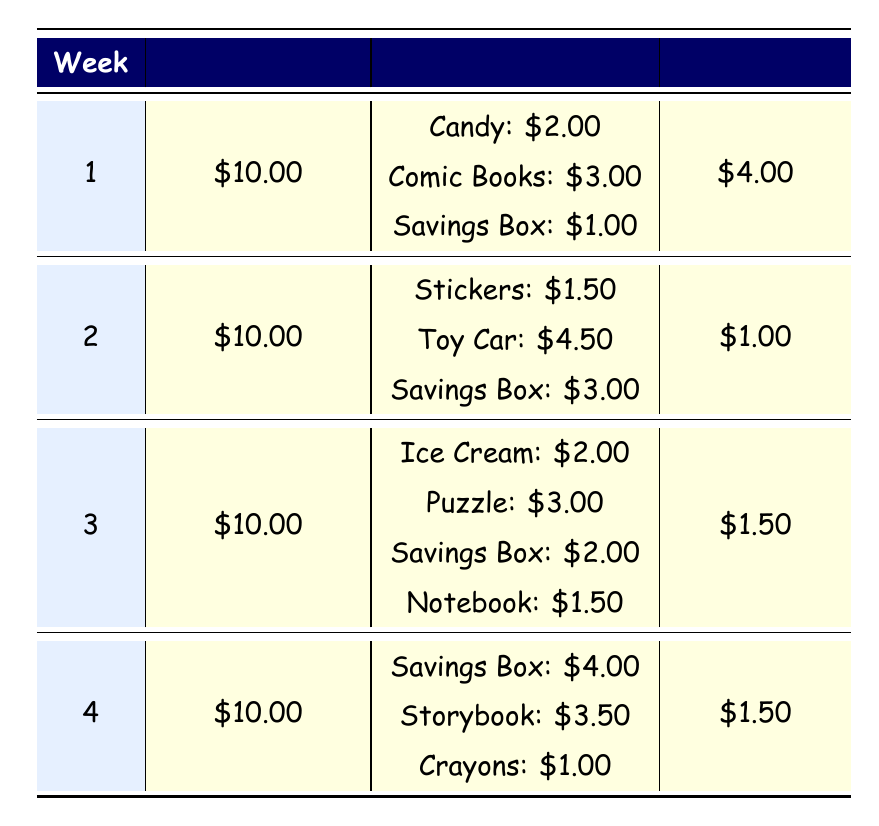What is the initial amount for week 1? The initial amount for week 1 is directly stated in the table as 10.00
Answer: 10.00 How much money was spent on comic books in week 1? The table lists the expenses for week 1, where the amount spent on comic books is 3.00
Answer: 3.00 What were the total expenses in week 2? To find the total expenses in week 2, I add the amounts from each expense category: Stickers (1.50) + Toy Car (4.50) + Savings Box (3.00) = 1.50 + 4.50 + 3.00 = 9.00
Answer: 9.00 Is the end amount in week 4 the same as in week 3? The end amount in week 4 is 1.50, and the end amount in week 3 is also 1.50. Since both amounts are identical, the answer is yes
Answer: Yes Which week had the highest end amount? I compare the end amounts for all weeks: Week 1 = 4.00, Week 2 = 1.00, Week 3 = 1.50, Week 4 = 1.50. The highest end amount is found in week 1 at 4.00
Answer: Week 1 How much was saved in the savings box during the four weeks? I need to sum up the amounts for the savings box across all weeks: Week 1 (1.00) + Week 2 (3.00) + Week 3 (2.00) + Week 4 (4.00) = 1.00 + 3.00 + 2.00 + 4.00 = 10.00
Answer: 10.00 What percentage of the initial amount was spent on crayons in week 4? First, I calculate the expense on crayons which is 1.00. Then, I find the percentage of the initial amount (10.00): (1.00 / 10.00) * 100 = 10%. Therefore, 10% of the initial amount was spent on crayons
Answer: 10% Was any week without expenses for savings box? Looking at the table, all weeks have some amount recorded for savings box: Week 1 (1.00), Week 2 (3.00), Week 3 (2.00), Week 4 (4.00). Thus, there are no weeks without expenses for savings box
Answer: No 